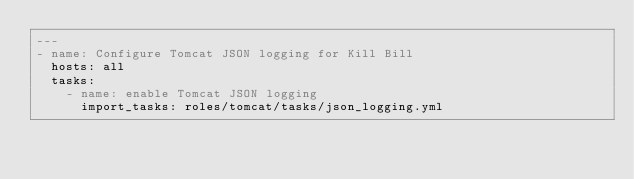<code> <loc_0><loc_0><loc_500><loc_500><_YAML_>---
- name: Configure Tomcat JSON logging for Kill Bill
  hosts: all
  tasks:
    - name: enable Tomcat JSON logging
      import_tasks: roles/tomcat/tasks/json_logging.yml
</code> 